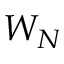Convert formula to latex. <formula><loc_0><loc_0><loc_500><loc_500>W _ { N }</formula> 